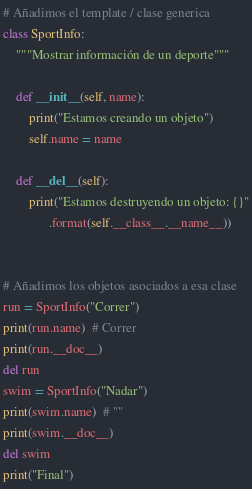<code> <loc_0><loc_0><loc_500><loc_500><_Python_># Añadimos el template / clase generica
class SportInfo:
    """Mostrar información de un deporte"""

    def __init__(self, name):
        print("Estamos creando un objeto")
        self.name = name

    def __del__(self):
        print("Estamos destruyendo un objeto: {}"
              .format(self.__class__.__name__))


# Añadimos los objetos asociados a esa clase
run = SportInfo("Correr")
print(run.name)  # Correr
print(run.__doc__)
del run 
swim = SportInfo("Nadar")
print(swim.name)  # ""
print(swim.__doc__)
del swim
print("Final")
</code> 